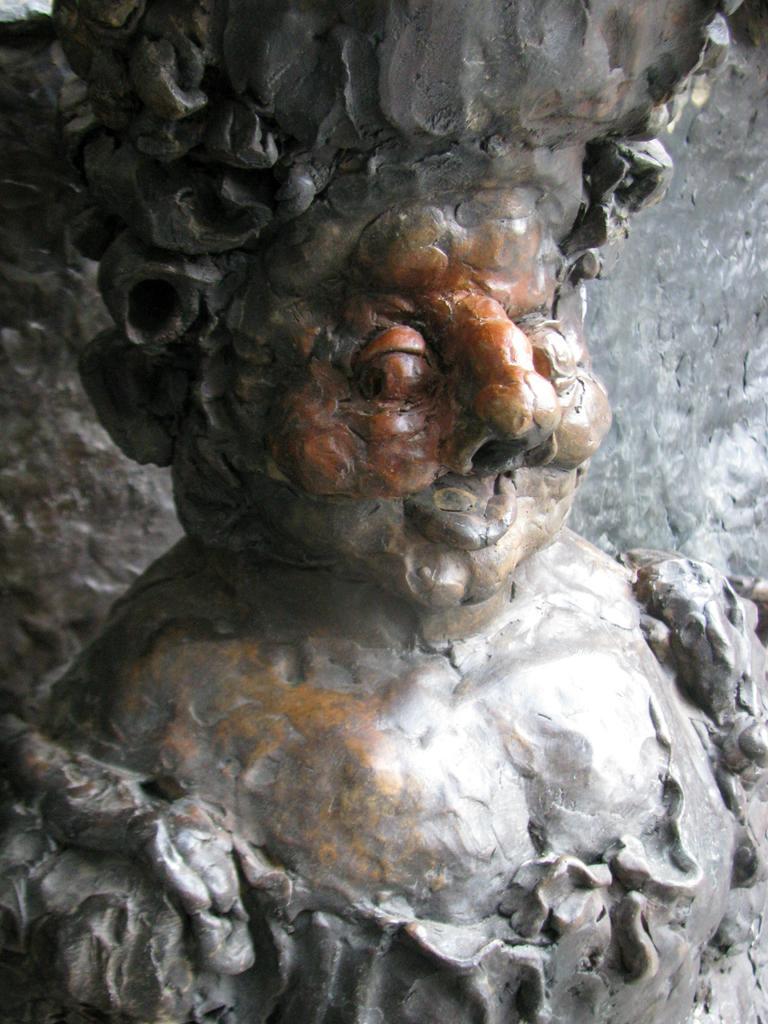Please provide a concise description of this image. This is a statue which is in the form human face with a mouth, nose and eyes. 